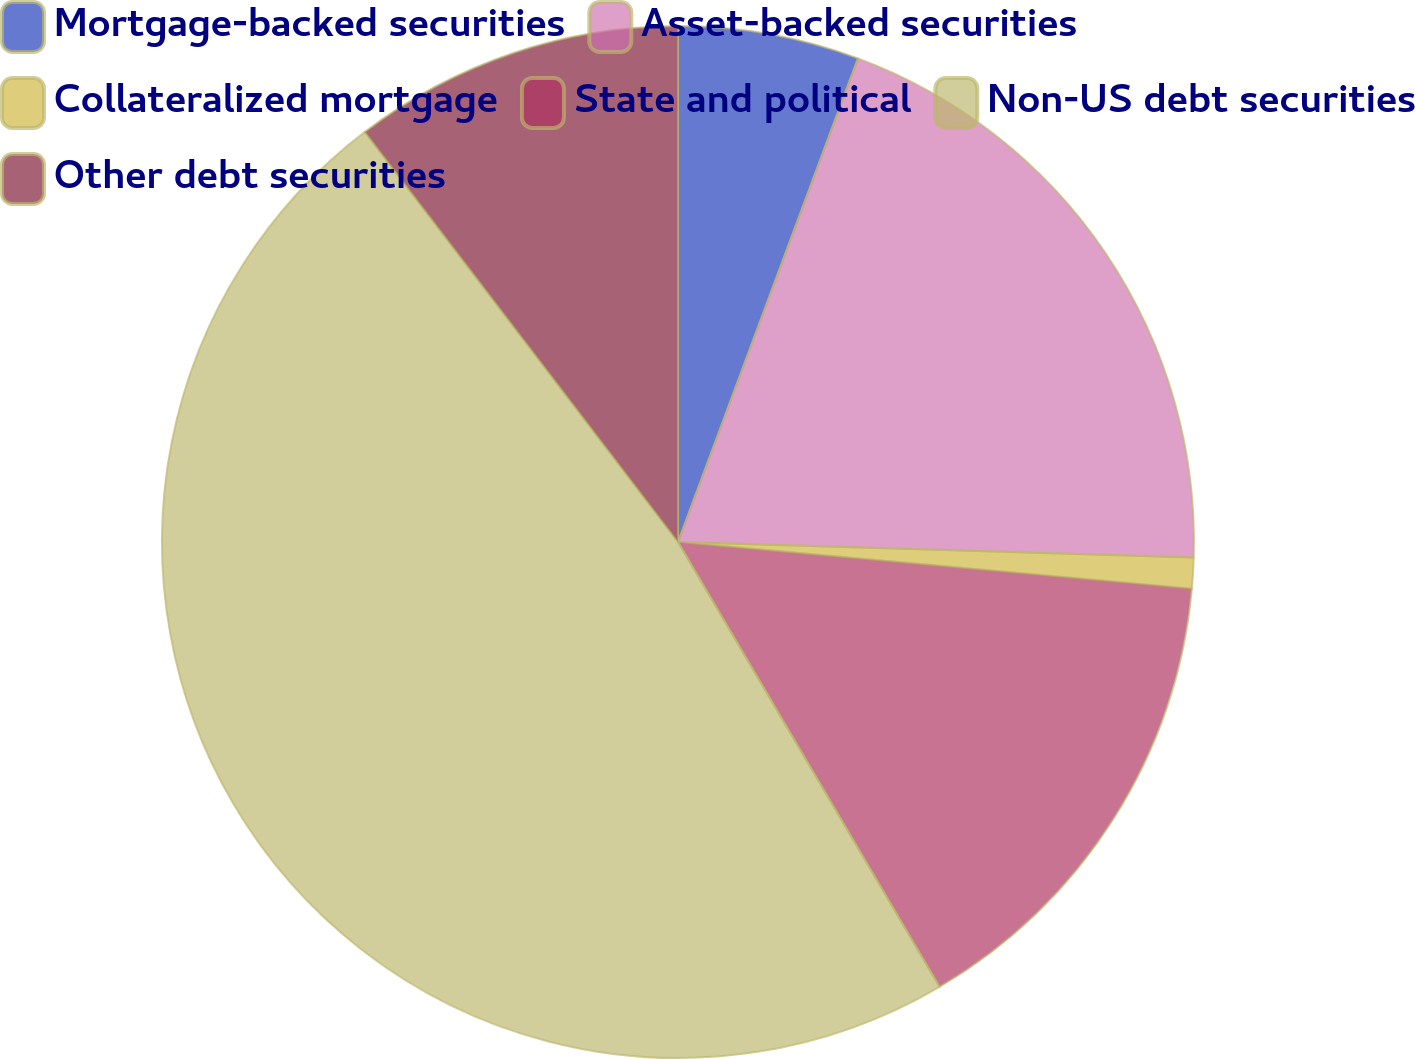Convert chart. <chart><loc_0><loc_0><loc_500><loc_500><pie_chart><fcel>Mortgage-backed securities<fcel>Asset-backed securities<fcel>Collateralized mortgage<fcel>State and political<fcel>Non-US debt securities<fcel>Other debt securities<nl><fcel>5.67%<fcel>19.81%<fcel>0.96%<fcel>15.1%<fcel>48.08%<fcel>10.38%<nl></chart> 